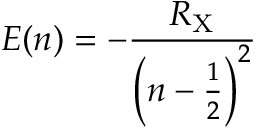<formula> <loc_0><loc_0><loc_500><loc_500>E ( n ) = - { \frac { R _ { X } } { \left ( n - { \frac { 1 } { 2 } } \right ) ^ { 2 } } }</formula> 